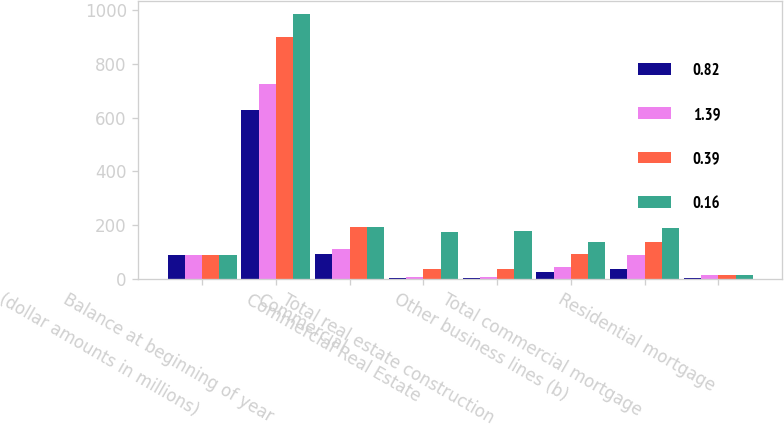Convert chart. <chart><loc_0><loc_0><loc_500><loc_500><stacked_bar_chart><ecel><fcel>(dollar amounts in millions)<fcel>Balance at beginning of year<fcel>Commercial<fcel>Commercial Real Estate<fcel>Total real estate construction<fcel>Other business lines (b)<fcel>Total commercial mortgage<fcel>Residential mortgage<nl><fcel>0.82<fcel>90<fcel>629<fcel>91<fcel>3<fcel>3<fcel>26<fcel>36<fcel>4<nl><fcel>1.39<fcel>90<fcel>726<fcel>112<fcel>7<fcel>8<fcel>43<fcel>89<fcel>13<nl><fcel>0.39<fcel>90<fcel>901<fcel>192<fcel>35<fcel>37<fcel>93<fcel>139<fcel>15<nl><fcel>0.16<fcel>90<fcel>985<fcel>195<fcel>175<fcel>179<fcel>138<fcel>191<fcel>14<nl></chart> 